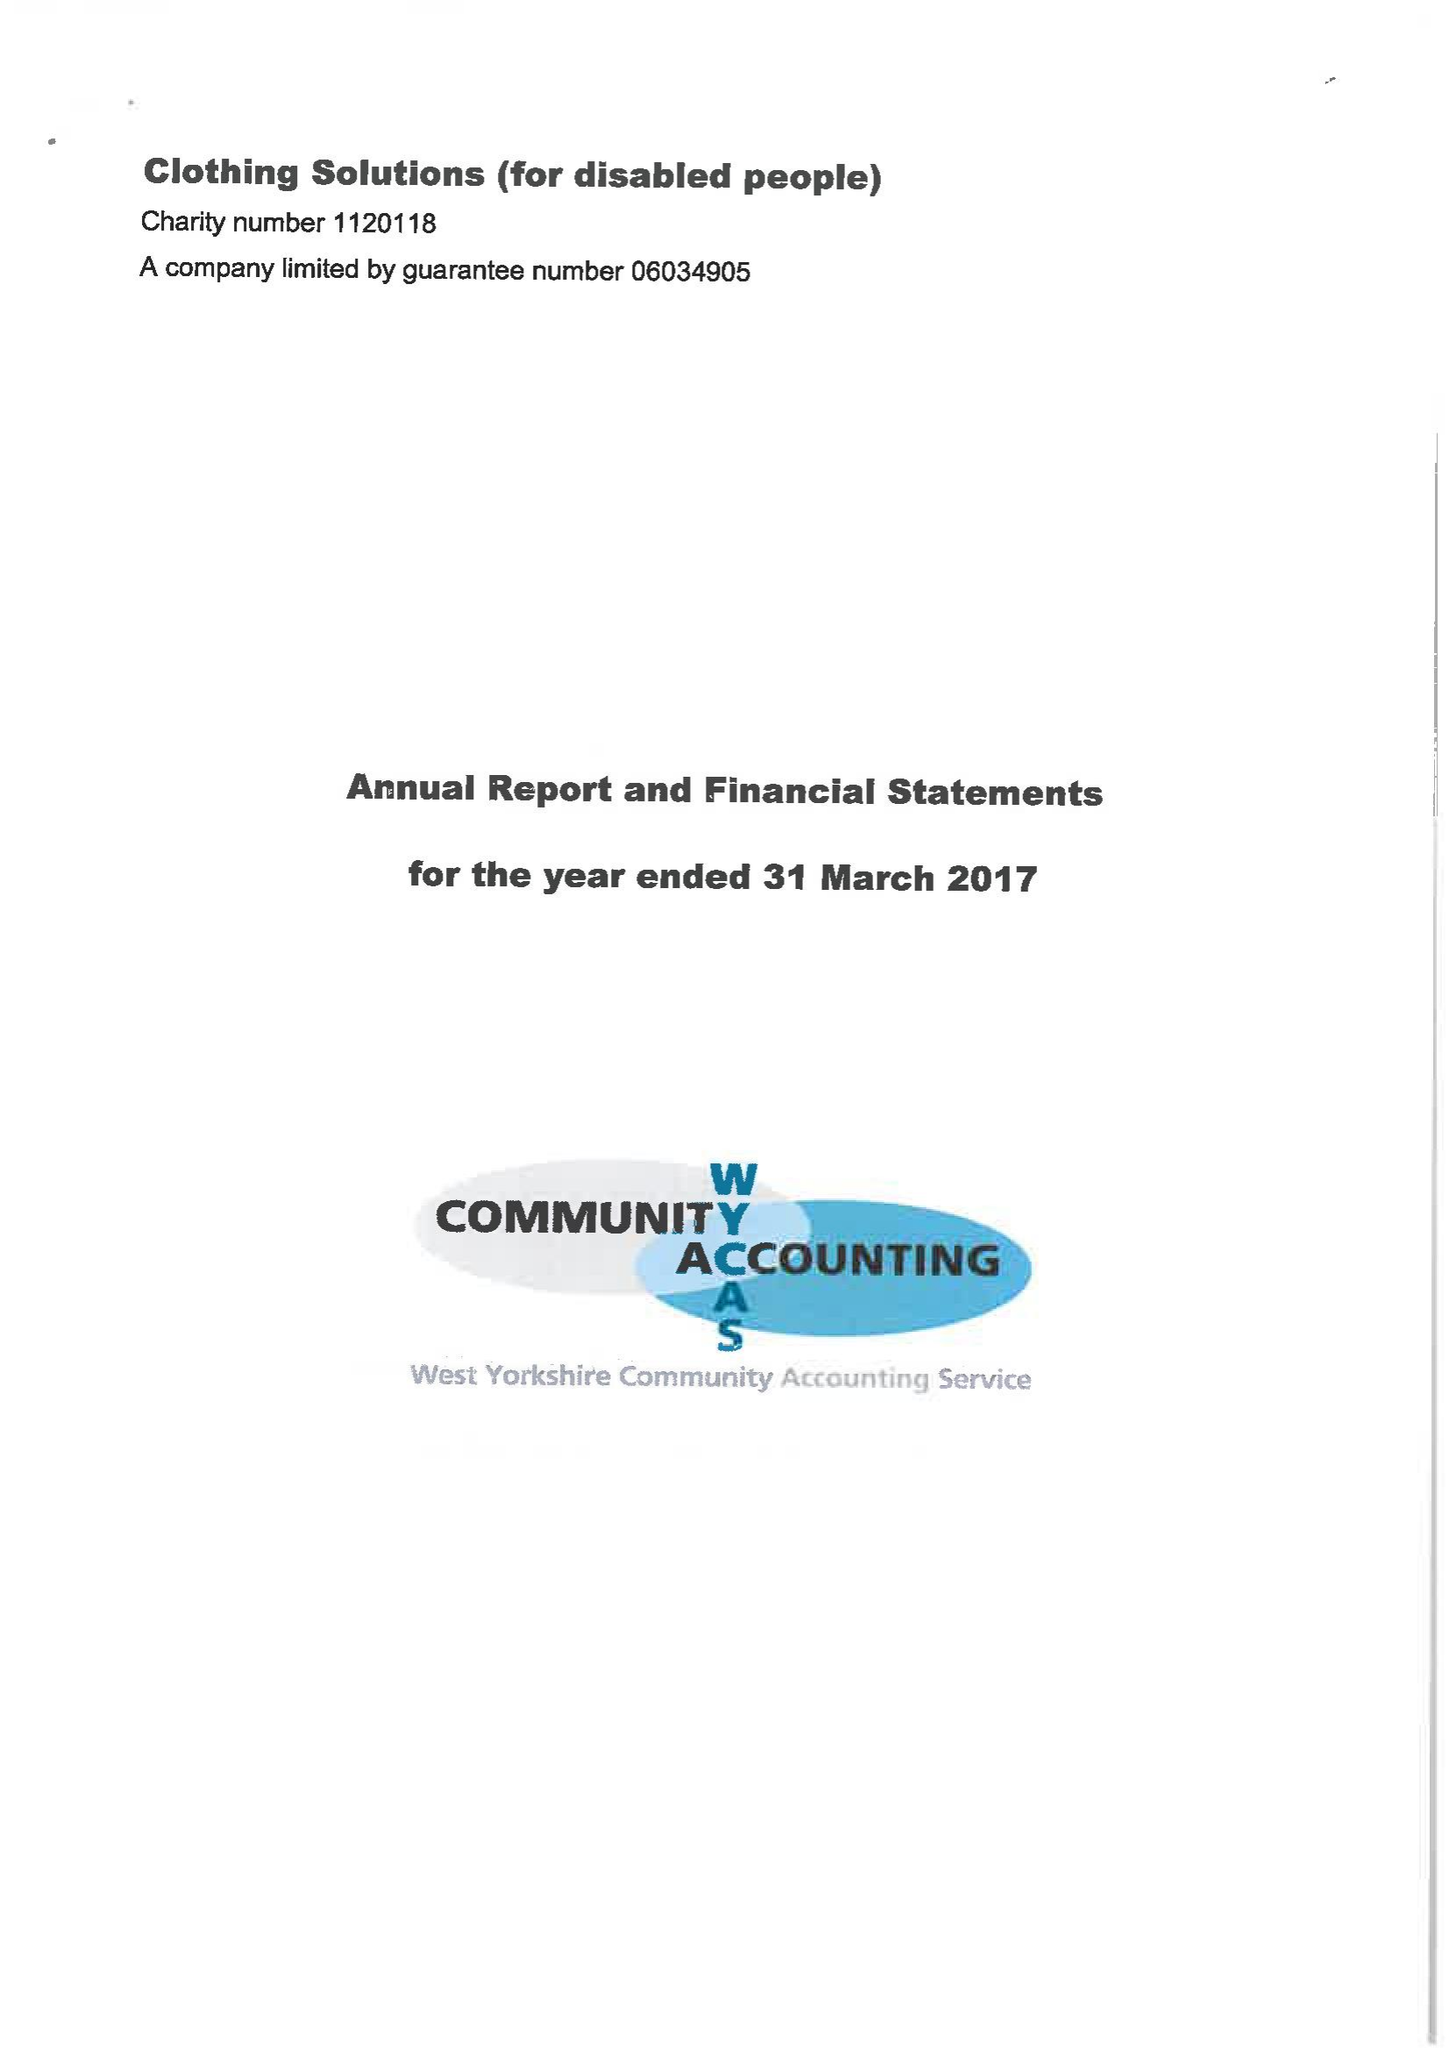What is the value for the report_date?
Answer the question using a single word or phrase. 2017-03-31 